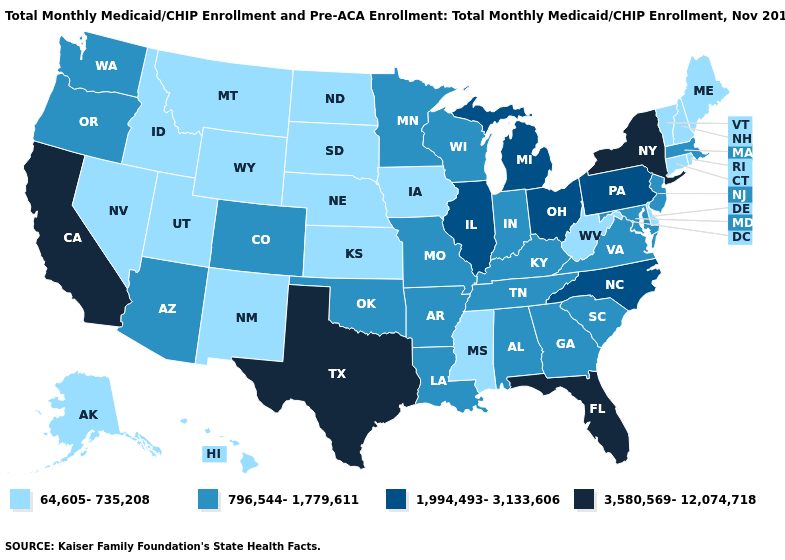Name the states that have a value in the range 796,544-1,779,611?
Keep it brief. Alabama, Arizona, Arkansas, Colorado, Georgia, Indiana, Kentucky, Louisiana, Maryland, Massachusetts, Minnesota, Missouri, New Jersey, Oklahoma, Oregon, South Carolina, Tennessee, Virginia, Washington, Wisconsin. Does the first symbol in the legend represent the smallest category?
Write a very short answer. Yes. What is the value of New Hampshire?
Write a very short answer. 64,605-735,208. Which states hav the highest value in the Northeast?
Answer briefly. New York. What is the highest value in the MidWest ?
Concise answer only. 1,994,493-3,133,606. Does California have the highest value in the West?
Quick response, please. Yes. Is the legend a continuous bar?
Give a very brief answer. No. What is the lowest value in states that border South Dakota?
Be succinct. 64,605-735,208. Name the states that have a value in the range 3,580,569-12,074,718?
Quick response, please. California, Florida, New York, Texas. Does Rhode Island have the same value as Colorado?
Write a very short answer. No. What is the value of Michigan?
Quick response, please. 1,994,493-3,133,606. What is the value of Tennessee?
Keep it brief. 796,544-1,779,611. Does Maryland have the highest value in the South?
Short answer required. No. Name the states that have a value in the range 1,994,493-3,133,606?
Keep it brief. Illinois, Michigan, North Carolina, Ohio, Pennsylvania. 